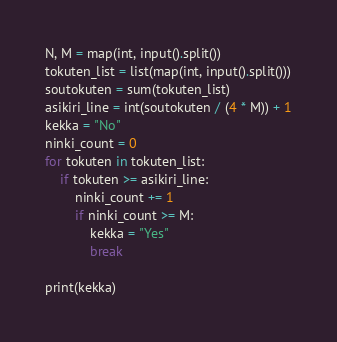<code> <loc_0><loc_0><loc_500><loc_500><_Python_>N, M = map(int, input().split())
tokuten_list = list(map(int, input().split()))
soutokuten = sum(tokuten_list)
asikiri_line = int(soutokuten / (4 * M)) + 1
kekka = "No"
ninki_count = 0
for tokuten in tokuten_list:
    if tokuten >= asikiri_line:
        ninki_count += 1
        if ninki_count >= M:
            kekka = "Yes"
            break

print(kekka)
</code> 